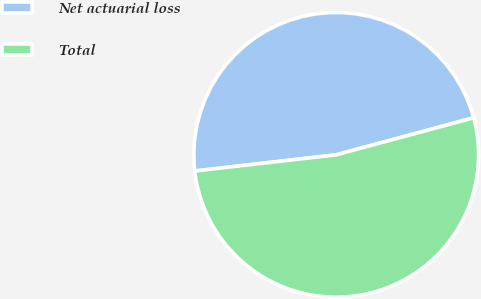Convert chart. <chart><loc_0><loc_0><loc_500><loc_500><pie_chart><fcel>Net actuarial loss<fcel>Total<nl><fcel>47.62%<fcel>52.38%<nl></chart> 